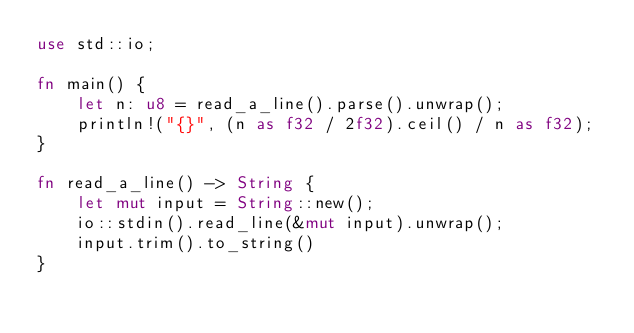<code> <loc_0><loc_0><loc_500><loc_500><_Rust_>use std::io;

fn main() {
    let n: u8 = read_a_line().parse().unwrap();
    println!("{}", (n as f32 / 2f32).ceil() / n as f32);
}

fn read_a_line() -> String {
    let mut input = String::new();
    io::stdin().read_line(&mut input).unwrap();
    input.trim().to_string()
}</code> 